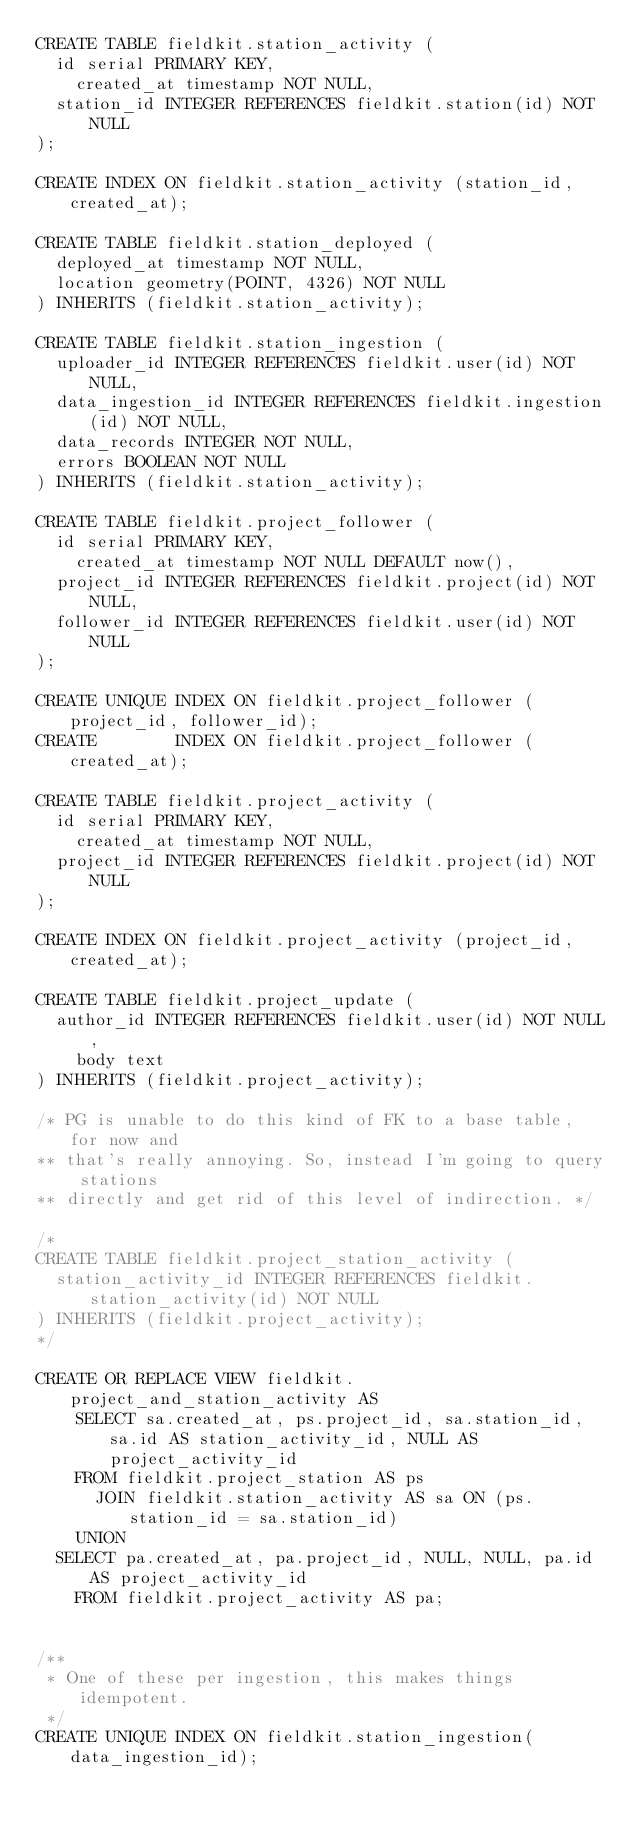<code> <loc_0><loc_0><loc_500><loc_500><_SQL_>CREATE TABLE fieldkit.station_activity (
	id serial PRIMARY KEY,
    created_at timestamp NOT NULL,
	station_id INTEGER REFERENCES fieldkit.station(id) NOT NULL
);

CREATE INDEX ON fieldkit.station_activity (station_id, created_at);

CREATE TABLE fieldkit.station_deployed (
	deployed_at timestamp NOT NULL,
	location geometry(POINT, 4326) NOT NULL
) INHERITS (fieldkit.station_activity);

CREATE TABLE fieldkit.station_ingestion (
	uploader_id INTEGER REFERENCES fieldkit.user(id) NOT NULL,
	data_ingestion_id INTEGER REFERENCES fieldkit.ingestion(id) NOT NULL,
	data_records INTEGER NOT NULL,
	errors BOOLEAN NOT NULL
) INHERITS (fieldkit.station_activity);

CREATE TABLE fieldkit.project_follower (
	id serial PRIMARY KEY,
    created_at timestamp NOT NULL DEFAULT now(),
	project_id INTEGER REFERENCES fieldkit.project(id) NOT NULL,
	follower_id INTEGER REFERENCES fieldkit.user(id) NOT NULL
);

CREATE UNIQUE INDEX ON fieldkit.project_follower (project_id, follower_id);
CREATE        INDEX ON fieldkit.project_follower (created_at);

CREATE TABLE fieldkit.project_activity (
	id serial PRIMARY KEY,
    created_at timestamp NOT NULL,
	project_id INTEGER REFERENCES fieldkit.project(id) NOT NULL
);

CREATE INDEX ON fieldkit.project_activity (project_id, created_at);

CREATE TABLE fieldkit.project_update (
	author_id INTEGER REFERENCES fieldkit.user(id) NOT NULL,
    body text
) INHERITS (fieldkit.project_activity);

/* PG is unable to do this kind of FK to a base table, for now and
** that's really annoying. So, instead I'm going to query stations
** directly and get rid of this level of indirection. */

/*
CREATE TABLE fieldkit.project_station_activity (
	station_activity_id INTEGER REFERENCES fieldkit.station_activity(id) NOT NULL
) INHERITS (fieldkit.project_activity);
*/

CREATE OR REPLACE VIEW fieldkit.project_and_station_activity AS
    SELECT sa.created_at, ps.project_id, sa.station_id, sa.id AS station_activity_id, NULL AS project_activity_id
	  FROM fieldkit.project_station AS ps
      JOIN fieldkit.station_activity AS sa ON (ps.station_id = sa.station_id)
    UNION
	SELECT pa.created_at, pa.project_id, NULL, NULL, pa.id AS project_activity_id
	  FROM fieldkit.project_activity AS pa;


/**
 * One of these per ingestion, this makes things idempotent.
 */
CREATE UNIQUE INDEX ON fieldkit.station_ingestion(data_ingestion_id);
</code> 